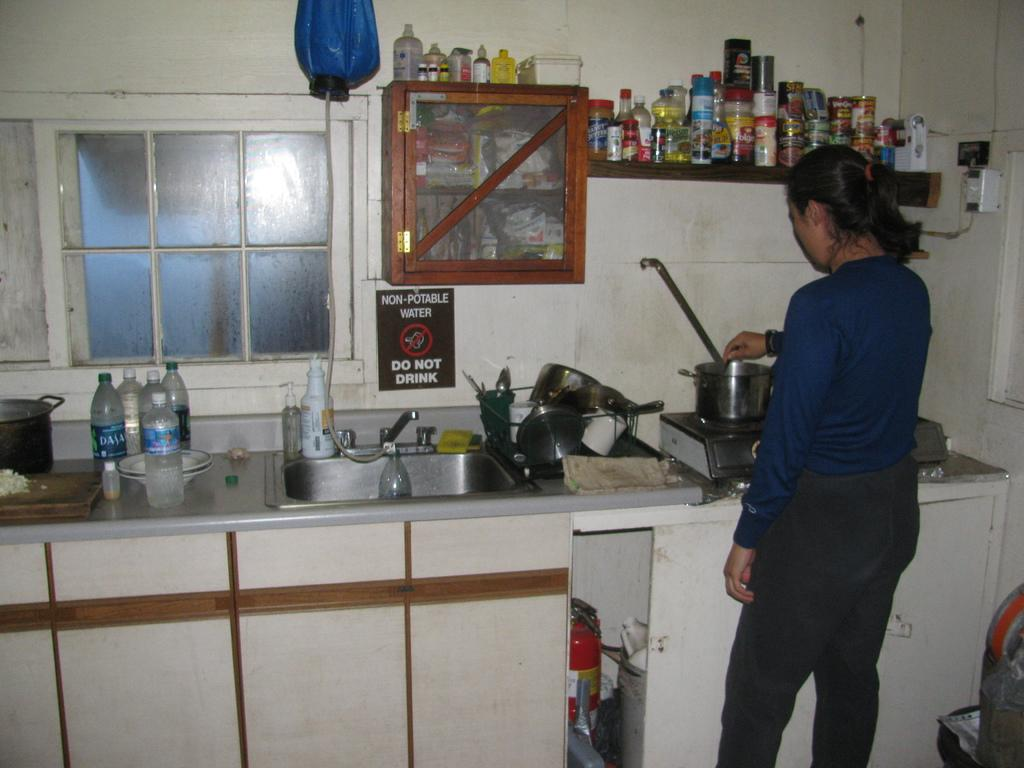<image>
Provide a brief description of the given image. A sign behind the sink warns not to drink the water 